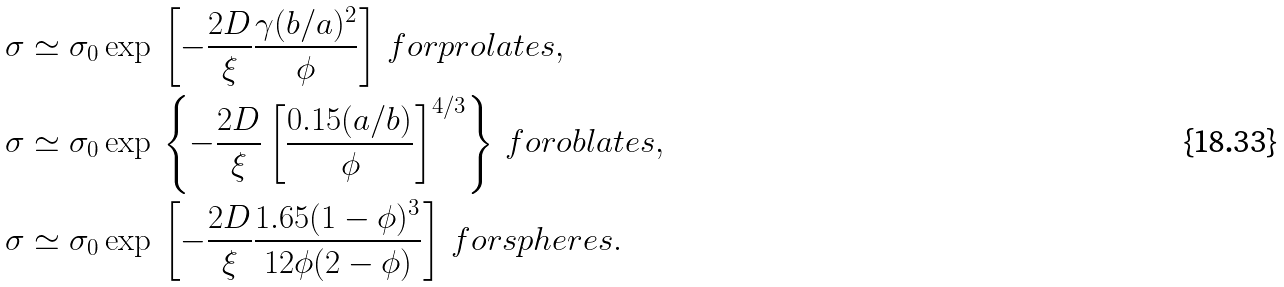Convert formula to latex. <formula><loc_0><loc_0><loc_500><loc_500>& \sigma \simeq \sigma _ { 0 } \exp \, \left [ - \frac { 2 D } { \xi } \frac { \gamma ( b / a ) ^ { 2 } } { \phi } \right ] \, f o r p r o l a t e s , \\ & \sigma \simeq \sigma _ { 0 } \exp \, \left \{ - \frac { 2 D } { \xi } \left [ \frac { 0 . 1 5 ( a / b ) } { \phi } \right ] ^ { 4 / 3 } \right \} \, f o r o b l a t e s , \\ & \sigma \simeq \sigma _ { 0 } \exp \, \left [ - \frac { 2 D } { \xi } \frac { 1 . 6 5 ( 1 - \phi ) ^ { 3 } } { 1 2 \phi ( 2 - \phi ) } \right ] \, f o r s p h e r e s .</formula> 